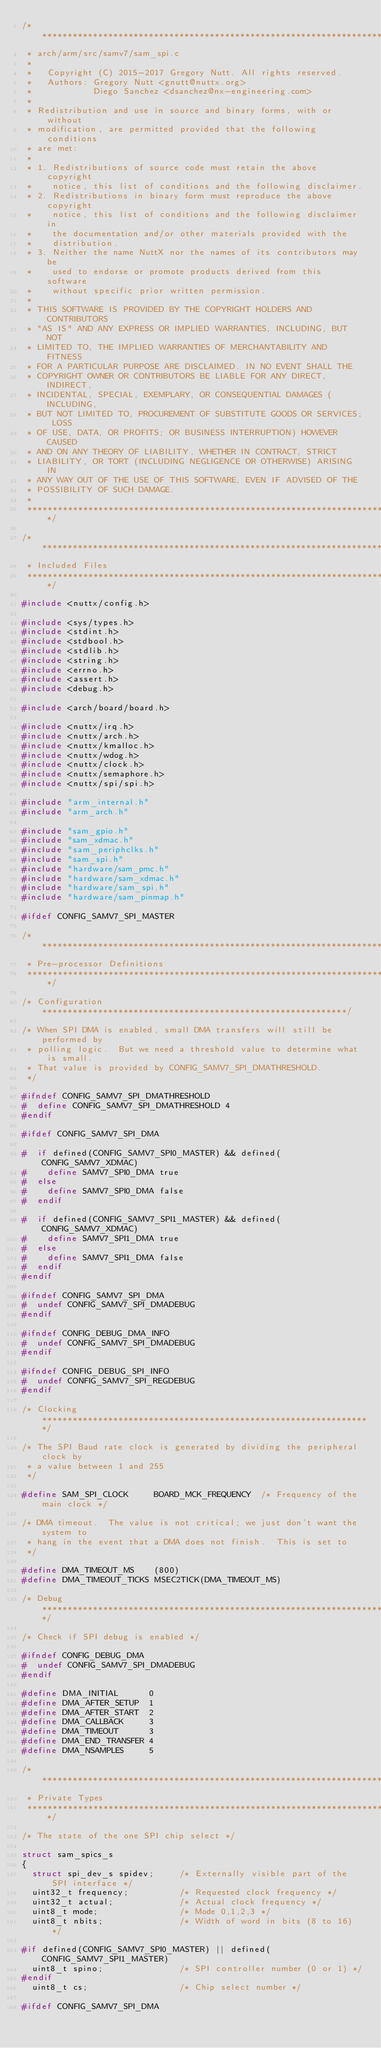<code> <loc_0><loc_0><loc_500><loc_500><_C_>/****************************************************************************
 * arch/arm/src/samv7/sam_spi.c
 *
 *   Copyright (C) 2015-2017 Gregory Nutt. All rights reserved.
 *   Authors: Gregory Nutt <gnutt@nuttx.org>
 *            Diego Sanchez <dsanchez@nx-engineering.com>
 *
 * Redistribution and use in source and binary forms, with or without
 * modification, are permitted provided that the following conditions
 * are met:
 *
 * 1. Redistributions of source code must retain the above copyright
 *    notice, this list of conditions and the following disclaimer.
 * 2. Redistributions in binary form must reproduce the above copyright
 *    notice, this list of conditions and the following disclaimer in
 *    the documentation and/or other materials provided with the
 *    distribution.
 * 3. Neither the name NuttX nor the names of its contributors may be
 *    used to endorse or promote products derived from this software
 *    without specific prior written permission.
 *
 * THIS SOFTWARE IS PROVIDED BY THE COPYRIGHT HOLDERS AND CONTRIBUTORS
 * "AS IS" AND ANY EXPRESS OR IMPLIED WARRANTIES, INCLUDING, BUT NOT
 * LIMITED TO, THE IMPLIED WARRANTIES OF MERCHANTABILITY AND FITNESS
 * FOR A PARTICULAR PURPOSE ARE DISCLAIMED. IN NO EVENT SHALL THE
 * COPYRIGHT OWNER OR CONTRIBUTORS BE LIABLE FOR ANY DIRECT, INDIRECT,
 * INCIDENTAL, SPECIAL, EXEMPLARY, OR CONSEQUENTIAL DAMAGES (INCLUDING,
 * BUT NOT LIMITED TO, PROCUREMENT OF SUBSTITUTE GOODS OR SERVICES; LOSS
 * OF USE, DATA, OR PROFITS; OR BUSINESS INTERRUPTION) HOWEVER CAUSED
 * AND ON ANY THEORY OF LIABILITY, WHETHER IN CONTRACT, STRICT
 * LIABILITY, OR TORT (INCLUDING NEGLIGENCE OR OTHERWISE) ARISING IN
 * ANY WAY OUT OF THE USE OF THIS SOFTWARE, EVEN IF ADVISED OF THE
 * POSSIBILITY OF SUCH DAMAGE.
 *
 ****************************************************************************/

/****************************************************************************
 * Included Files
 ****************************************************************************/

#include <nuttx/config.h>

#include <sys/types.h>
#include <stdint.h>
#include <stdbool.h>
#include <stdlib.h>
#include <string.h>
#include <errno.h>
#include <assert.h>
#include <debug.h>

#include <arch/board/board.h>

#include <nuttx/irq.h>
#include <nuttx/arch.h>
#include <nuttx/kmalloc.h>
#include <nuttx/wdog.h>
#include <nuttx/clock.h>
#include <nuttx/semaphore.h>
#include <nuttx/spi/spi.h>

#include "arm_internal.h"
#include "arm_arch.h"

#include "sam_gpio.h"
#include "sam_xdmac.h"
#include "sam_periphclks.h"
#include "sam_spi.h"
#include "hardware/sam_pmc.h"
#include "hardware/sam_xdmac.h"
#include "hardware/sam_spi.h"
#include "hardware/sam_pinmap.h"

#ifdef CONFIG_SAMV7_SPI_MASTER

/****************************************************************************
 * Pre-processor Definitions
 ****************************************************************************/

/* Configuration ************************************************************/

/* When SPI DMA is enabled, small DMA transfers will still be performed by
 * polling logic.  But we need a threshold value to determine what is small.
 * That value is provided by CONFIG_SAMV7_SPI_DMATHRESHOLD.
 */

#ifndef CONFIG_SAMV7_SPI_DMATHRESHOLD
#  define CONFIG_SAMV7_SPI_DMATHRESHOLD 4
#endif

#ifdef CONFIG_SAMV7_SPI_DMA

#  if defined(CONFIG_SAMV7_SPI0_MASTER) && defined(CONFIG_SAMV7_XDMAC)
#    define SAMV7_SPI0_DMA true
#  else
#    define SAMV7_SPI0_DMA false
#  endif

#  if defined(CONFIG_SAMV7_SPI1_MASTER) && defined(CONFIG_SAMV7_XDMAC)
#    define SAMV7_SPI1_DMA true
#  else
#    define SAMV7_SPI1_DMA false
#  endif
#endif

#ifndef CONFIG_SAMV7_SPI_DMA
#  undef CONFIG_SAMV7_SPI_DMADEBUG
#endif

#ifndef CONFIG_DEBUG_DMA_INFO
#  undef CONFIG_SAMV7_SPI_DMADEBUG
#endif

#ifndef CONFIG_DEBUG_SPI_INFO
#  undef CONFIG_SAMV7_SPI_REGDEBUG
#endif

/* Clocking *****************************************************************/

/* The SPI Baud rate clock is generated by dividing the peripheral clock by
 * a value between 1 and 255
 */

#define SAM_SPI_CLOCK     BOARD_MCK_FREQUENCY  /* Frequency of the main clock */

/* DMA timeout.  The value is not critical; we just don't want the system to
 * hang in the event that a DMA does not finish.  This is set to
 */

#define DMA_TIMEOUT_MS    (800)
#define DMA_TIMEOUT_TICKS MSEC2TICK(DMA_TIMEOUT_MS)

/* Debug ********************************************************************/

/* Check if SPI debug is enabled */

#ifndef CONFIG_DEBUG_DMA
#  undef CONFIG_SAMV7_SPI_DMADEBUG
#endif

#define DMA_INITIAL      0
#define DMA_AFTER_SETUP  1
#define DMA_AFTER_START  2
#define DMA_CALLBACK     3
#define DMA_TIMEOUT      3
#define DMA_END_TRANSFER 4
#define DMA_NSAMPLES     5

/****************************************************************************
 * Private Types
 ****************************************************************************/

/* The state of the one SPI chip select */

struct sam_spics_s
{
  struct spi_dev_s spidev;     /* Externally visible part of the SPI interface */
  uint32_t frequency;          /* Requested clock frequency */
  uint32_t actual;             /* Actual clock frequency */
  uint8_t mode;                /* Mode 0,1,2,3 */
  uint8_t nbits;               /* Width of word in bits (8 to 16) */

#if defined(CONFIG_SAMV7_SPI0_MASTER) || defined(CONFIG_SAMV7_SPI1_MASTER)
  uint8_t spino;               /* SPI controller number (0 or 1) */
#endif
  uint8_t cs;                  /* Chip select number */

#ifdef CONFIG_SAMV7_SPI_DMA</code> 